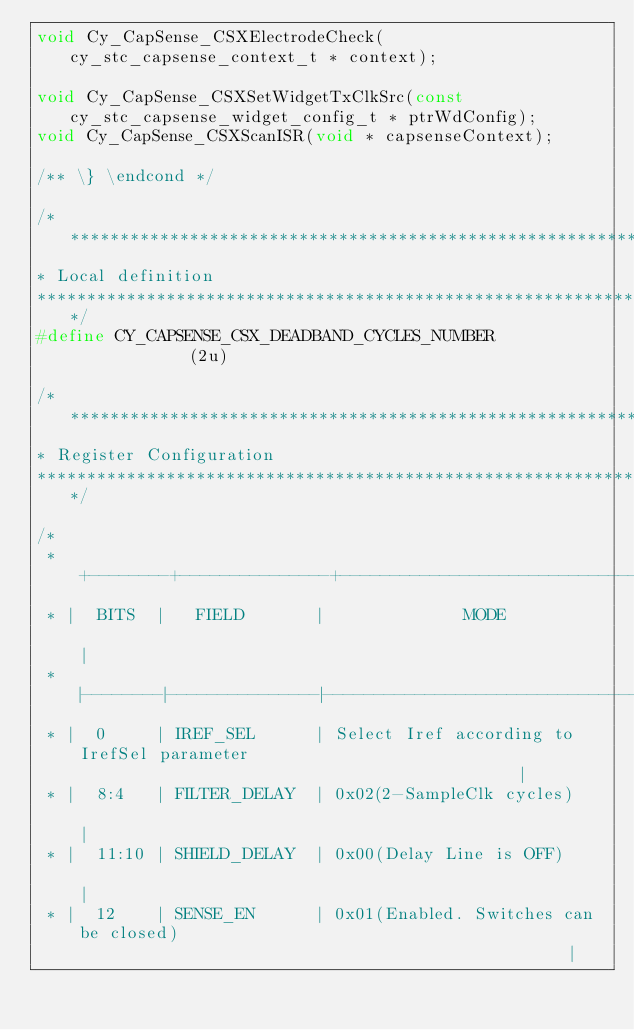<code> <loc_0><loc_0><loc_500><loc_500><_C_>void Cy_CapSense_CSXElectrodeCheck(cy_stc_capsense_context_t * context);

void Cy_CapSense_CSXSetWidgetTxClkSrc(const cy_stc_capsense_widget_config_t * ptrWdConfig);
void Cy_CapSense_CSXScanISR(void * capsenseContext);

/** \} \endcond */

/*******************************************************************************
* Local definition
*******************************************************************************/
#define CY_CAPSENSE_CSX_DEADBAND_CYCLES_NUMBER             (2u)

/*******************************************************************************
* Register Configuration
*******************************************************************************/

/*
 * +--------+---------------+----------------------------------------------------------------------------------------+
 * |  BITS  |   FIELD       |              MODE                                                                      |
 * |--------|---------------|----------------------------------------------------------------------------------------|
 * |  0     | IREF_SEL      | Select Iref according to IrefSel parameter                                             |
 * |  8:4   | FILTER_DELAY  | 0x02(2-SampleClk cycles)                                                               |
 * |  11:10 | SHIELD_DELAY  | 0x00(Delay Line is OFF)                                                                |
 * |  12    | SENSE_EN      | 0x01(Enabled. Switches can be closed)                                                  |</code> 